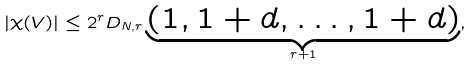<formula> <loc_0><loc_0><loc_500><loc_500>| \chi ( V ) | \leq 2 ^ { r } D _ { N , r } \underbrace { ( 1 , 1 + d , \dots , 1 + d ) } _ { r + 1 } ,</formula> 